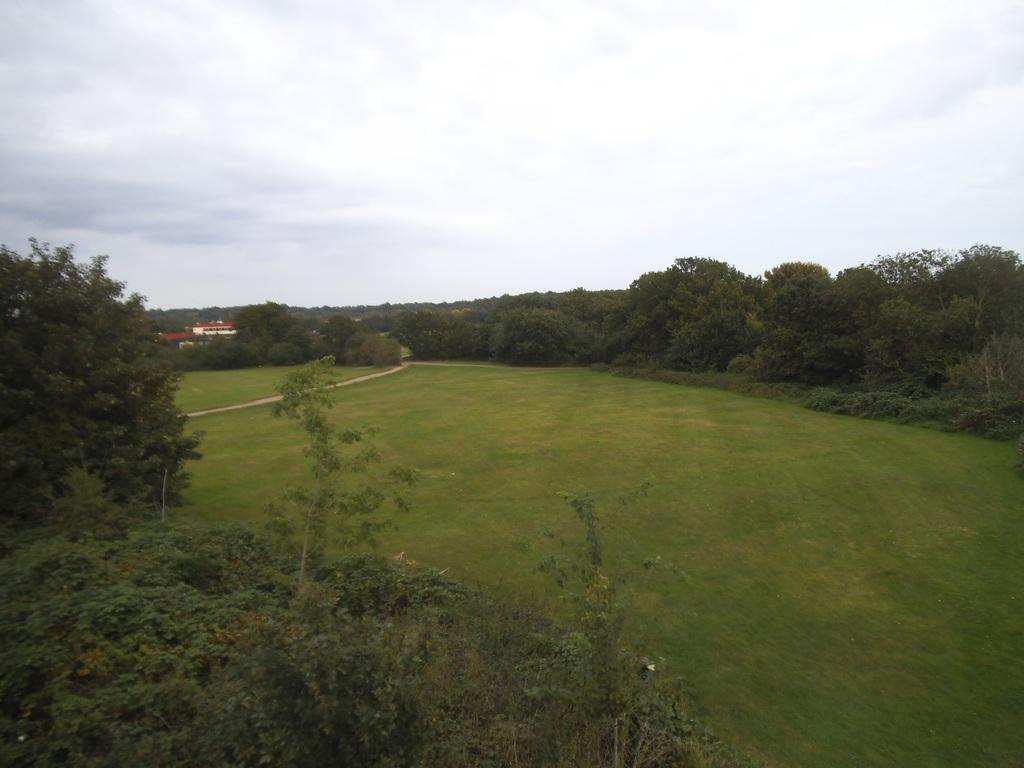How would you summarize this image in a sentence or two? In this image there is a green field, in the background there a trees,house,and a sky in the left side there are trees. 